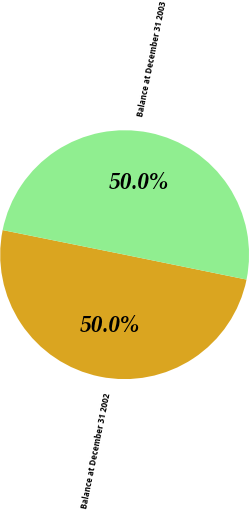Convert chart. <chart><loc_0><loc_0><loc_500><loc_500><pie_chart><fcel>Balance at December 31 2002<fcel>Balance at December 31 2003<nl><fcel>49.96%<fcel>50.04%<nl></chart> 